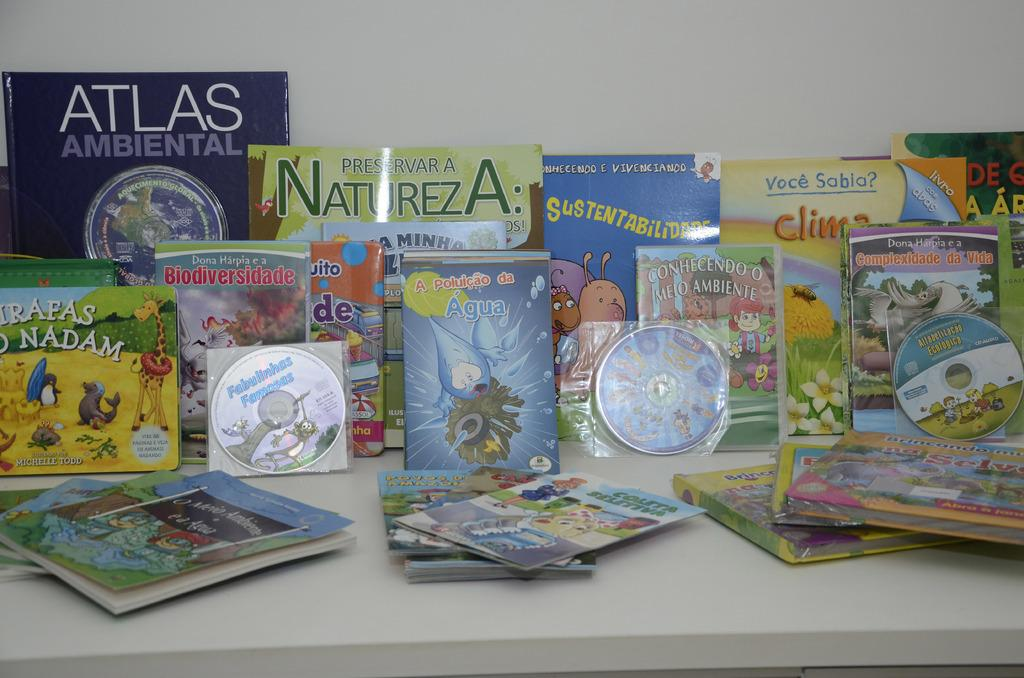<image>
Create a compact narrative representing the image presented. Children's books on the table and leaning against the wall in a row. 